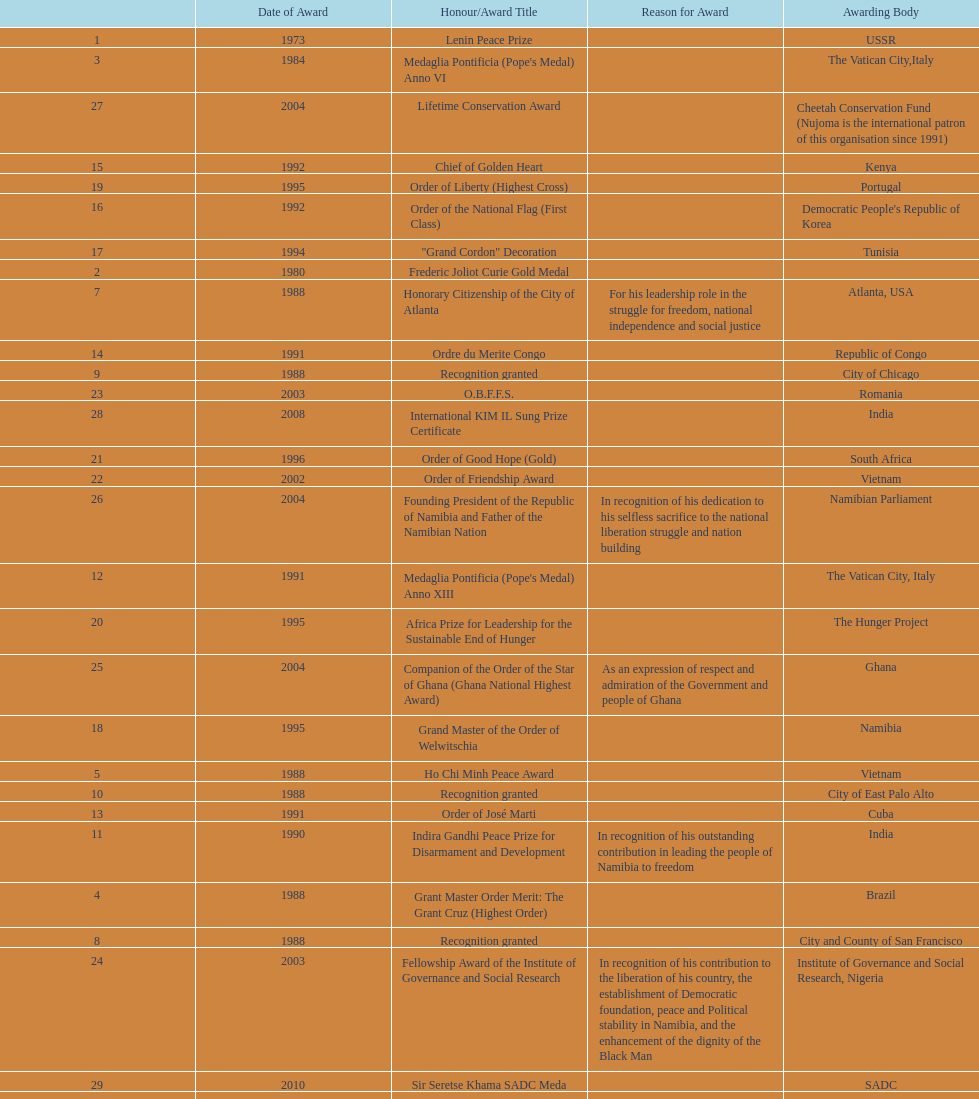Could you help me parse every detail presented in this table? {'header': ['', 'Date of Award', 'Honour/Award Title', 'Reason for Award', 'Awarding Body'], 'rows': [['1', '1973', 'Lenin Peace Prize', '', 'USSR'], ['3', '1984', "Medaglia Pontificia (Pope's Medal) Anno VI", '', 'The Vatican City,Italy'], ['27', '2004', 'Lifetime Conservation Award', '', 'Cheetah Conservation Fund (Nujoma is the international patron of this organisation since 1991)'], ['15', '1992', 'Chief of Golden Heart', '', 'Kenya'], ['19', '1995', 'Order of Liberty (Highest Cross)', '', 'Portugal'], ['16', '1992', 'Order of the National Flag (First Class)', '', "Democratic People's Republic of Korea"], ['17', '1994', '"Grand Cordon" Decoration', '', 'Tunisia'], ['2', '1980', 'Frederic Joliot Curie Gold Medal', '', ''], ['7', '1988', 'Honorary Citizenship of the City of Atlanta', 'For his leadership role in the struggle for freedom, national independence and social justice', 'Atlanta, USA'], ['14', '1991', 'Ordre du Merite Congo', '', 'Republic of Congo'], ['9', '1988', 'Recognition granted', '', 'City of Chicago'], ['23', '2003', 'O.B.F.F.S.', '', 'Romania'], ['28', '2008', 'International KIM IL Sung Prize Certificate', '', 'India'], ['21', '1996', 'Order of Good Hope (Gold)', '', 'South Africa'], ['22', '2002', 'Order of Friendship Award', '', 'Vietnam'], ['26', '2004', 'Founding President of the Republic of Namibia and Father of the Namibian Nation', 'In recognition of his dedication to his selfless sacrifice to the national liberation struggle and nation building', 'Namibian Parliament'], ['12', '1991', "Medaglia Pontificia (Pope's Medal) Anno XIII", '', 'The Vatican City, Italy'], ['20', '1995', 'Africa Prize for Leadership for the Sustainable End of Hunger', '', 'The Hunger Project'], ['25', '2004', 'Companion of the Order of the Star of Ghana (Ghana National Highest Award)', 'As an expression of respect and admiration of the Government and people of Ghana', 'Ghana'], ['18', '1995', 'Grand Master of the Order of Welwitschia', '', 'Namibia'], ['5', '1988', 'Ho Chi Minh Peace Award', '', 'Vietnam'], ['10', '1988', 'Recognition granted', '', 'City of East Palo Alto'], ['13', '1991', 'Order of José Marti', '', 'Cuba'], ['11', '1990', 'Indira Gandhi Peace Prize for Disarmament and Development', 'In recognition of his outstanding contribution in leading the people of Namibia to freedom', 'India'], ['4', '1988', 'Grant Master Order Merit: The Grant Cruz (Highest Order)', '', 'Brazil'], ['8', '1988', 'Recognition granted', '', 'City and County of San Francisco'], ['24', '2003', 'Fellowship Award of the Institute of Governance and Social Research', 'In recognition of his contribution to the liberation of his country, the establishment of Democratic foundation, peace and Political stability in Namibia, and the enhancement of the dignity of the Black Man', 'Institute of Governance and Social Research, Nigeria'], ['29', '2010', 'Sir Seretse Khama SADC Meda', '', 'SADC'], ['6', '1988', 'The Namibia Freedom Award', 'For his leadership role in the struggle against apartheid', 'California State University, USA']]} What is the most recent award nujoma received? Sir Seretse Khama SADC Meda. 